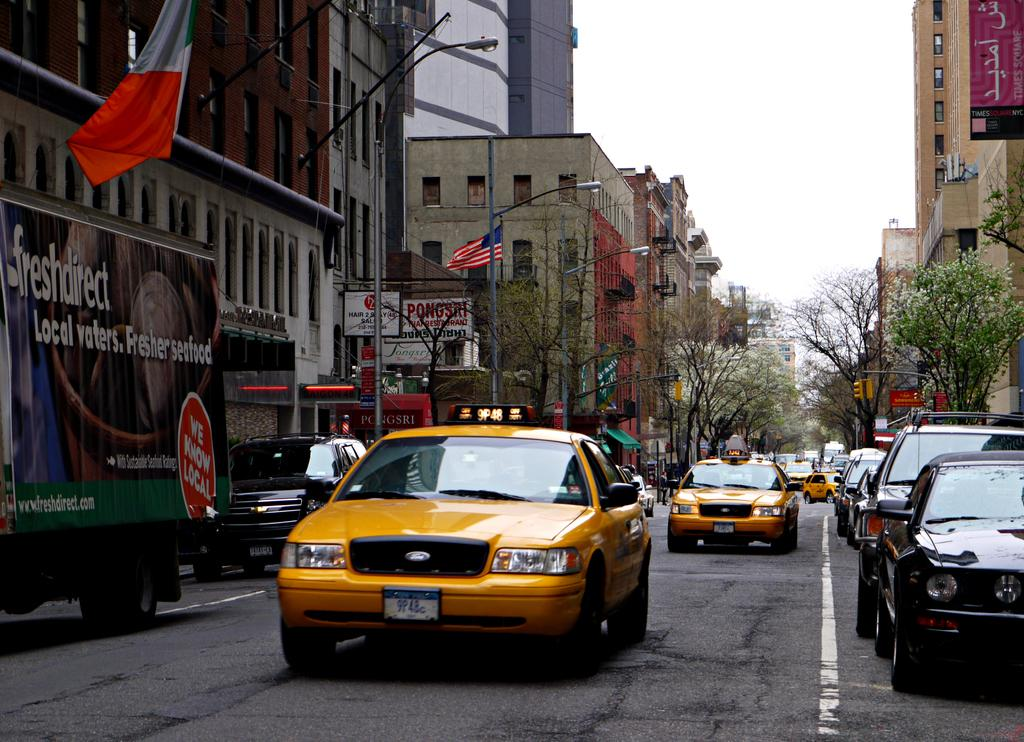Provide a one-sentence caption for the provided image. A freshdirect truck is next to a yellow cab. 